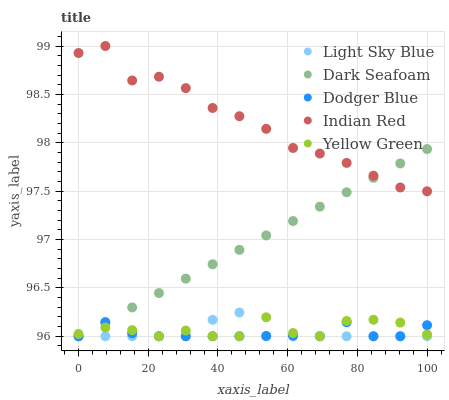Does Dodger Blue have the minimum area under the curve?
Answer yes or no. Yes. Does Indian Red have the maximum area under the curve?
Answer yes or no. Yes. Does Light Sky Blue have the minimum area under the curve?
Answer yes or no. No. Does Light Sky Blue have the maximum area under the curve?
Answer yes or no. No. Is Dark Seafoam the smoothest?
Answer yes or no. Yes. Is Indian Red the roughest?
Answer yes or no. Yes. Is Light Sky Blue the smoothest?
Answer yes or no. No. Is Light Sky Blue the roughest?
Answer yes or no. No. Does Dark Seafoam have the lowest value?
Answer yes or no. Yes. Does Indian Red have the lowest value?
Answer yes or no. No. Does Indian Red have the highest value?
Answer yes or no. Yes. Does Light Sky Blue have the highest value?
Answer yes or no. No. Is Yellow Green less than Indian Red?
Answer yes or no. Yes. Is Indian Red greater than Dodger Blue?
Answer yes or no. Yes. Does Dodger Blue intersect Light Sky Blue?
Answer yes or no. Yes. Is Dodger Blue less than Light Sky Blue?
Answer yes or no. No. Is Dodger Blue greater than Light Sky Blue?
Answer yes or no. No. Does Yellow Green intersect Indian Red?
Answer yes or no. No. 